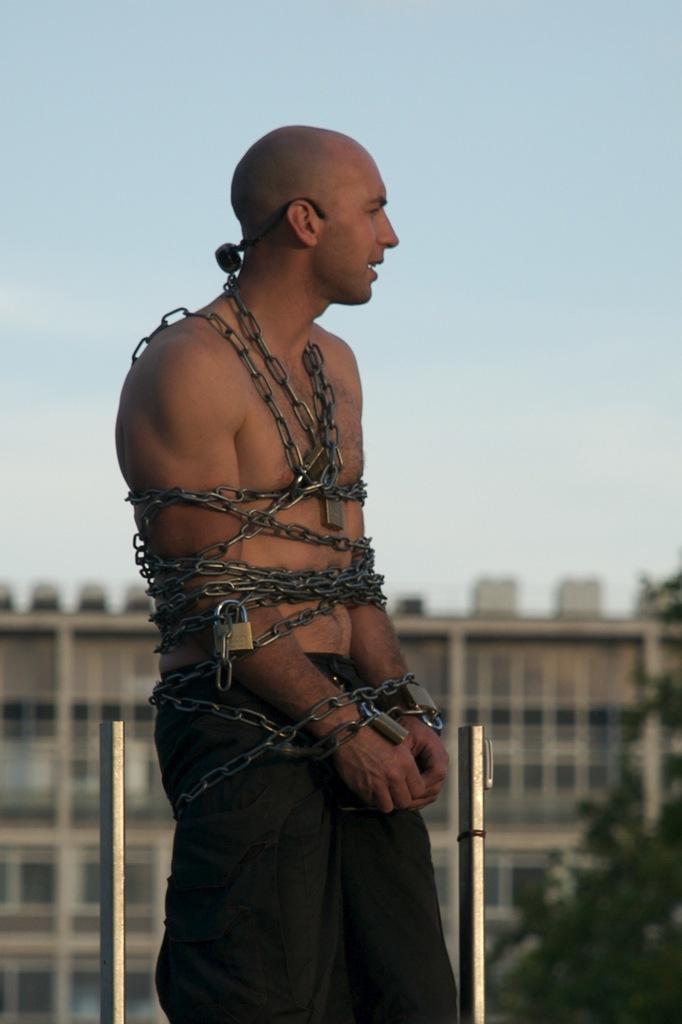Describe this image in one or two sentences. In this picture I can observe a man. He is tied with chains. There are two poles on either sides of him. In the background there is a building and I can observe some trees. There is a sky in the background. 